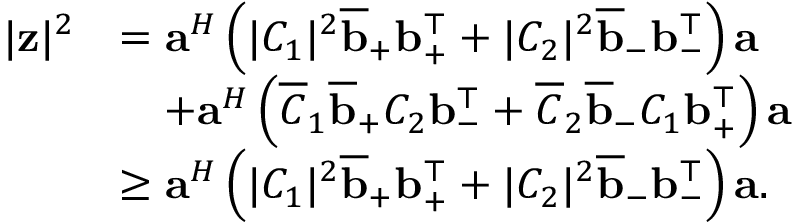Convert formula to latex. <formula><loc_0><loc_0><loc_500><loc_500>\begin{array} { r l } { | \mathbf z | ^ { 2 } } & { = a ^ { H } \left ( | C _ { 1 } | ^ { 2 } \overline { b } _ { + } b _ { + } ^ { \top } + | C _ { 2 } | ^ { 2 } \overline { b } _ { - } b _ { - } ^ { \top } \right ) a } \\ & { \quad + a ^ { H } \left ( \overline { C } _ { 1 } \overline { b } _ { + } C _ { 2 } b _ { - } ^ { \top } + \overline { C } _ { 2 } \overline { b } _ { - } C _ { 1 } b _ { + } ^ { \top } \right ) a } \\ & { \geq a ^ { H } \left ( | C _ { 1 } | ^ { 2 } \overline { b } _ { + } b _ { + } ^ { \top } + | C _ { 2 } | ^ { 2 } \overline { b } _ { - } b _ { - } ^ { \top } \right ) a . } \end{array}</formula> 